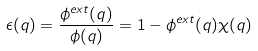<formula> <loc_0><loc_0><loc_500><loc_500>\epsilon ( q ) = \frac { { \phi ^ { e x t } ( q ) } } { \phi ( q ) } = 1 - \phi ^ { e x t } ( q ) \chi ( q )</formula> 